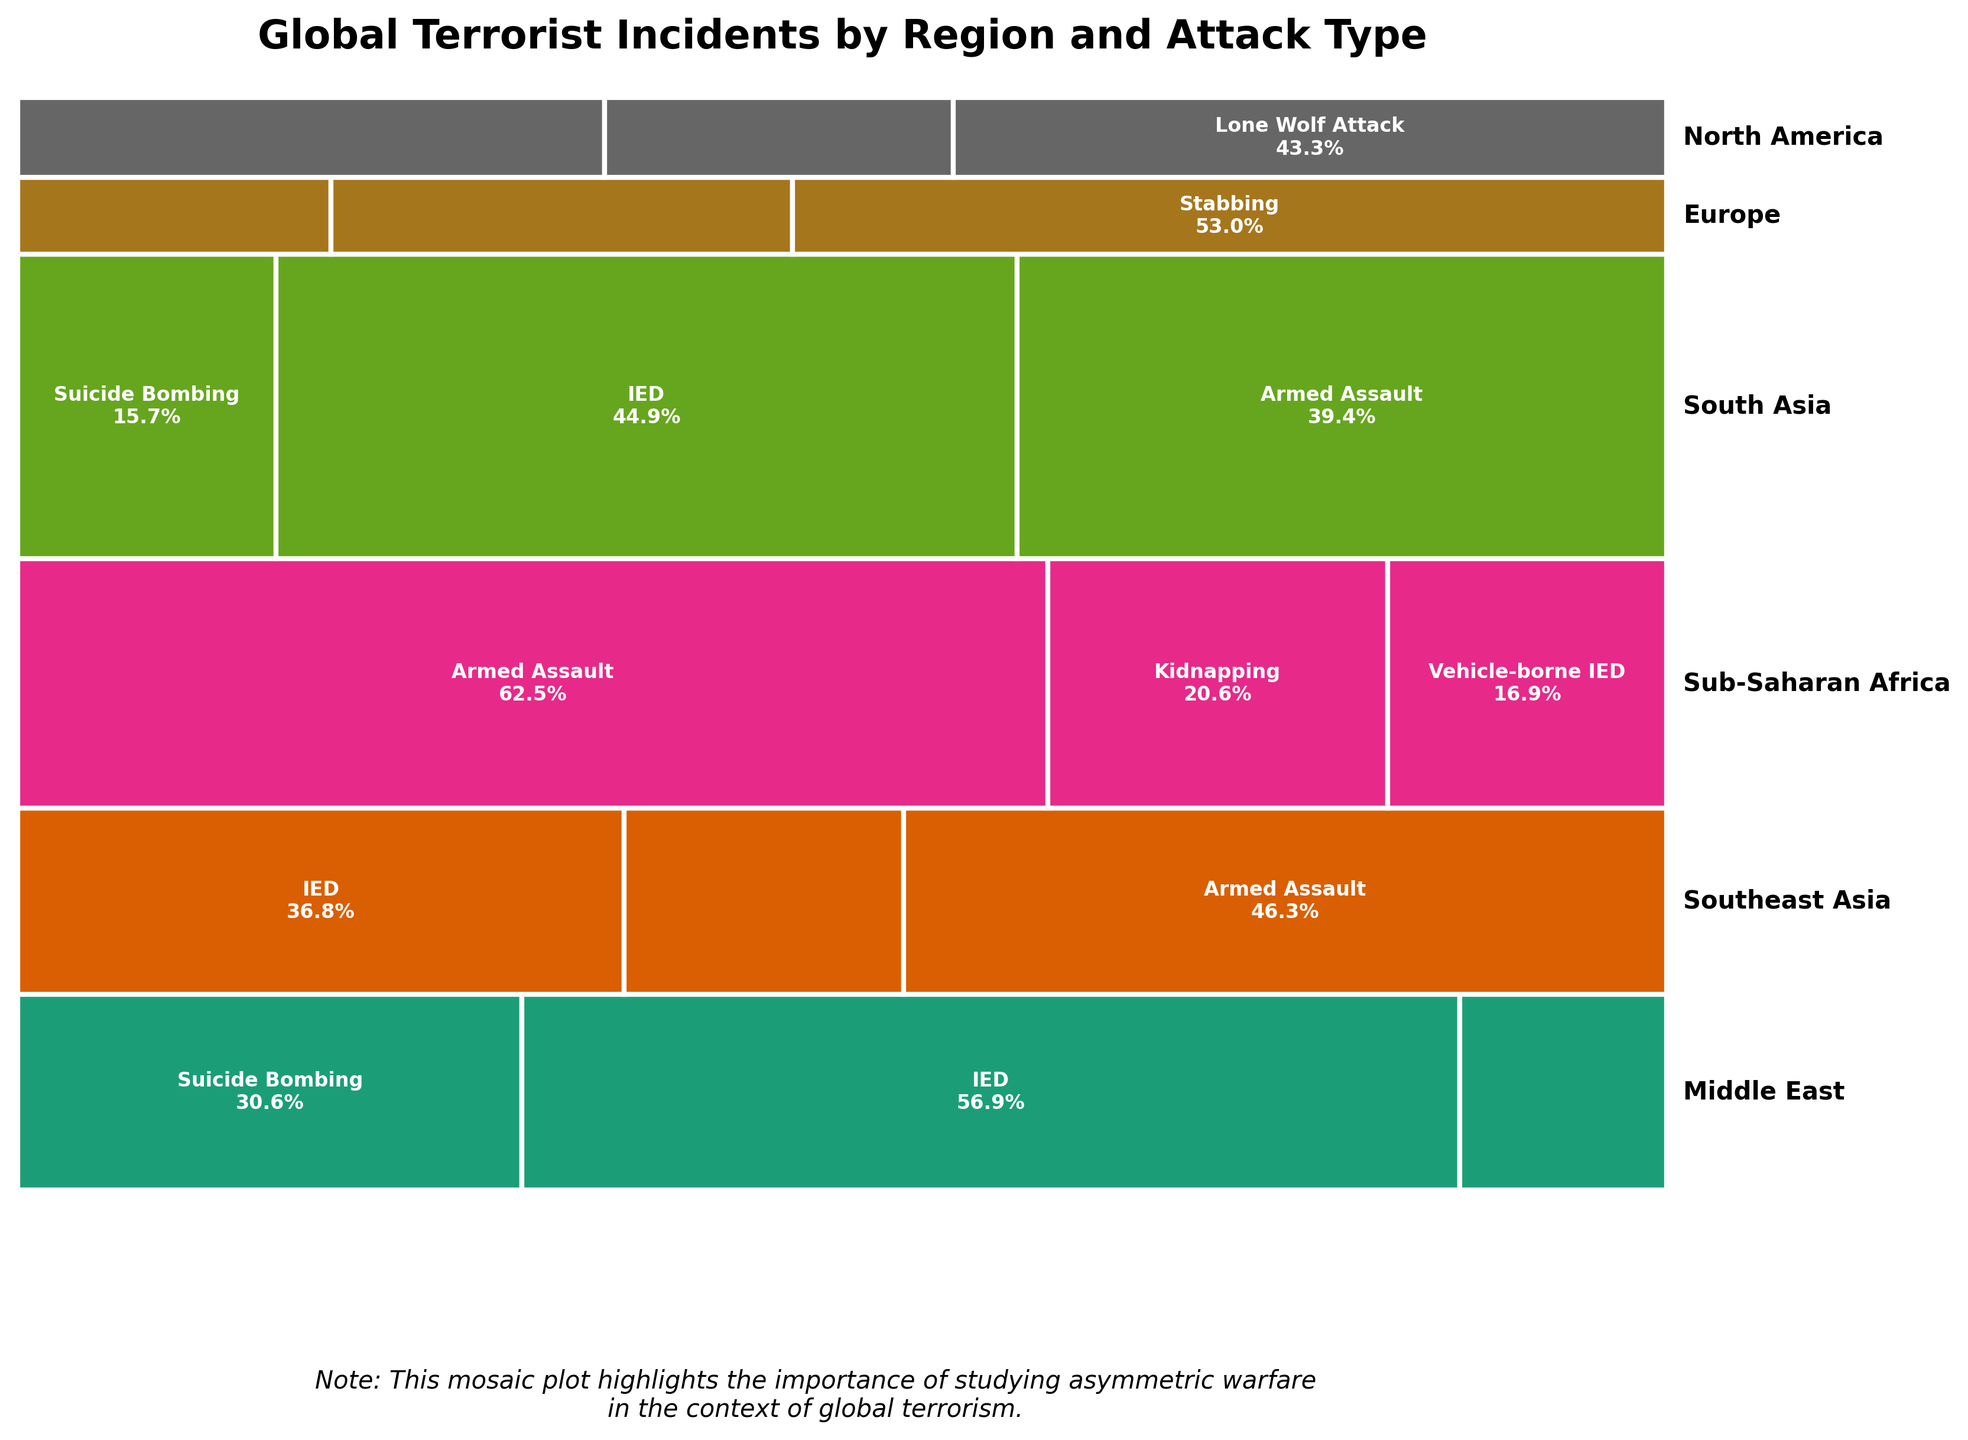What is the main plot title? The plot title is displayed prominently above the mosaic plot.
Answer: "Global Terrorist Incidents by Region and Attack Type" Which region experienced the highest number of terrorist incidents involving IEDs? By examining the rectangles, identify the region with the largest area dedicated to IEDs. South Asia has the highest percentage for the IED attack type.
Answer: South Asia What percentage of terrorist incidents in North America are Lone Wolf Attacks? Look at the rectangle for Lone Wolf Attacks in North America and read the percentage displayed within or near it.
Answer: 45% Which attack type is most prominent in Sub-Saharan Africa? Identify the attack type with the largest rectangle within the Sub-Saharan Africa section. This would be Armed Assault as indicated by the larger area.
Answer: Armed Assault Among Europe, North America, and Southeast Asia, which region has the lowest total number of terrorist incidents? Compare the heights of rectangles associated with each region. Europe has the smallest height, indicating the fewest total incidents.
Answer: Europe How do the incident counts for Suicide Bombing in the Middle East compare to those in South Asia? Evaluate the sizes of the rectangles for Suicide Bombing in both Middle East and South Asia. The percentage and size for the Middle East are slightly larger than those for South Asia.
Answer: Middle East has more than South Asia What is unique about the attack types listed for North America compared to other regions? Observe the attack types shown for North America and note anything not seen in other regions; Cyber Attack is unique to North America.
Answer: Cyber Attack is unique Which region has the most variety in attack types? Examine the number of different attack types listed within each region. Middle East and South Asia both contain varied types of attacks, but Southeast Asia has the most variety.
Answer: Southeast Asia What fraction of incidents in Middle East are due to IED attacks? Identify the percentage for IED attacks in the Middle East, and since IED's rectangle is almost half of the total for Middle East, it rounds to approximately half.
Answer: About 50% 